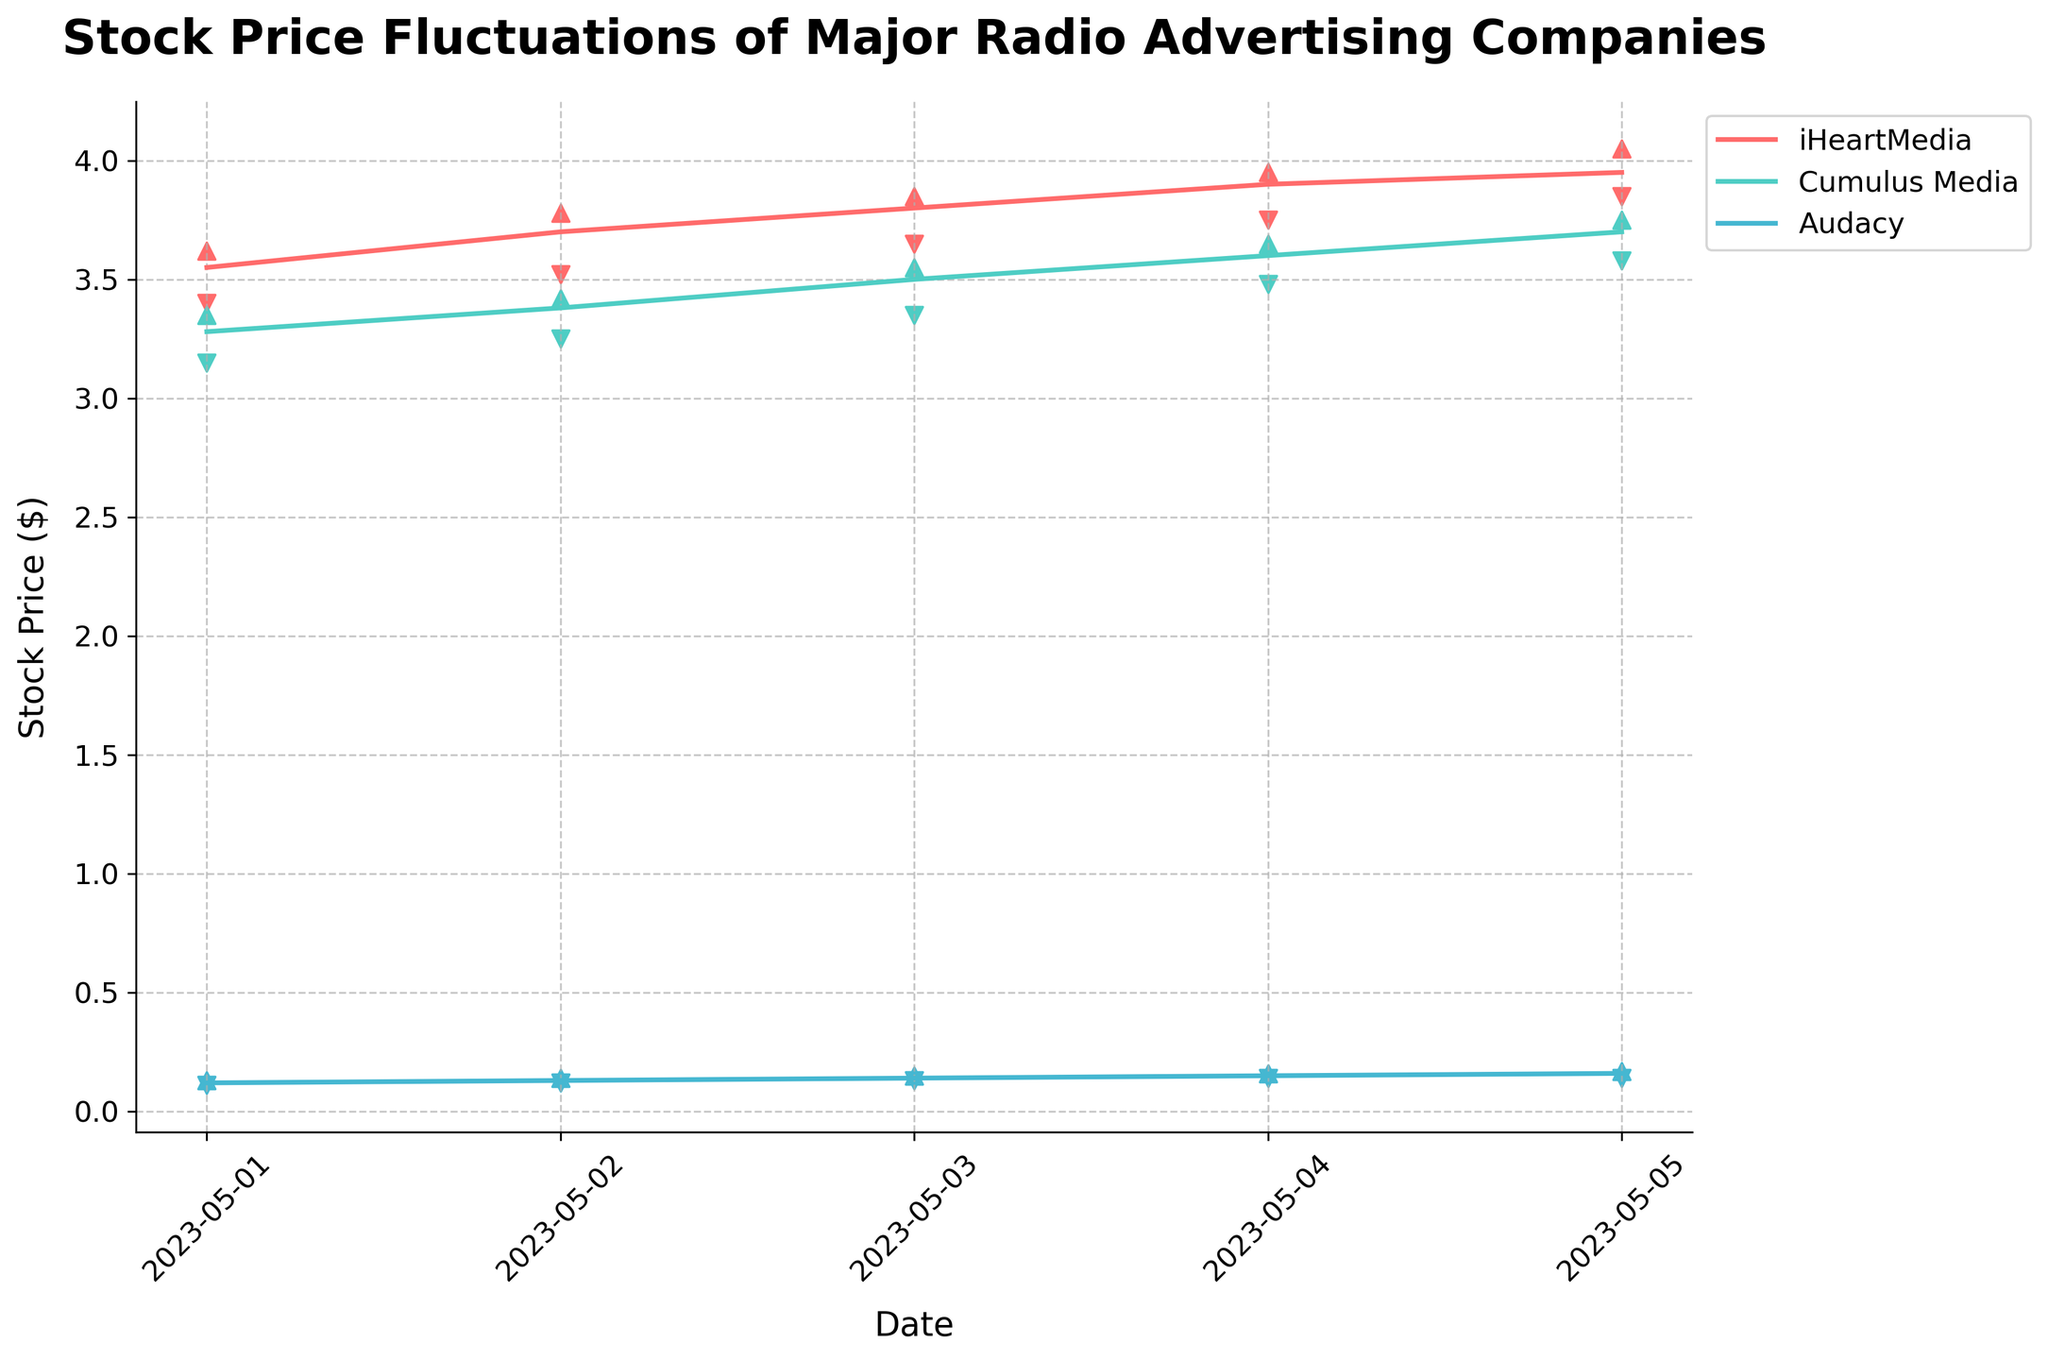What is the title of the chart? The title of the chart is displayed at the top and reads: 'Stock Price Fluctuations of Major Radio Advertising Companies'.
Answer: Stock Price Fluctuations of Major Radio Advertising Companies How many companies are represented in the chart? The chart has different lines and markers for each company, and there are three colors representing three companies.
Answer: 3 Which company has the lowest closing price on May 5, 2023? Check the closing prices for each company on May 5, 2023, and identify the lowest. Audacy has the lowest closing price of $0.16.
Answer: Audacy Between May 1, 2023, and May 5, 2023, which company shows the highest overall increase in their closing price? Compare the closing prices on May 1, 2023, and May 5, 2023 for each company:
- iHeartMedia: $3.55 to $3.95
- Cumulus Media: $3.28 to $3.70
- Audacy: $0.12 to $0.16
iHeartMedia shows the highest increase ($0.40).
Answer: iHeartMedia On which date did iHeartMedia experience the greatest difference between its high and low prices? Calculate the difference between high and low prices for iHeartMedia across the dates and identify the greatest difference:
- May 1: $0.22
- May 2: $0.26
- May 3: $0.20
- May 4: $0.20
- May 5: $0.20
The greatest difference is on May 2 ($0.26).
Answer: May 2 Which company's stock prices are represented by the color teal? Based on the legend that describes which company corresponds to which color, Cumulus Media is represented by the color teal.
Answer: Cumulus Media Did Cumulus Media's stock price close higher than its opening price on May 3, 2023? Check Cumulus Media's opening and closing prices for May 3, 2023: Open = $3.40 and Close = $3.50. The stock closed higher than its opening price.
Answer: Yes Which company had the highest closing price on May 3, 2023? Compare the closing prices of each company on May 3, 2023:
- iHeartMedia: $3.80
- Cumulus Media: $3.50
- Audacy: $0.14
iHeartMedia had the highest closing price.
Answer: iHeartMedia By how much did Audacy's closing price increase from May 1, 2023, to May 5, 2023? Calculate the difference in closing prices for Audacy between May 1 and May 5, 2023: $0.16 - $0.12 = $0.04.
Answer: $0.04 